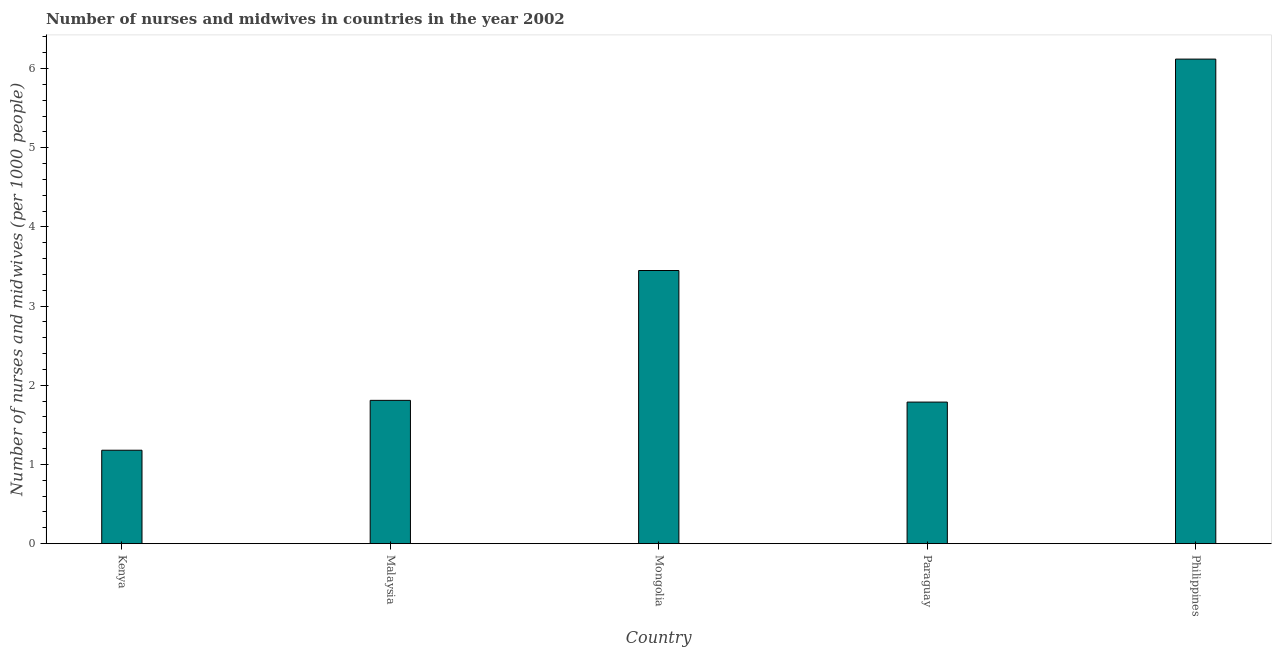Does the graph contain any zero values?
Offer a very short reply. No. What is the title of the graph?
Your answer should be compact. Number of nurses and midwives in countries in the year 2002. What is the label or title of the Y-axis?
Your answer should be very brief. Number of nurses and midwives (per 1000 people). What is the number of nurses and midwives in Mongolia?
Offer a very short reply. 3.45. Across all countries, what is the maximum number of nurses and midwives?
Offer a terse response. 6.12. Across all countries, what is the minimum number of nurses and midwives?
Provide a short and direct response. 1.18. In which country was the number of nurses and midwives minimum?
Give a very brief answer. Kenya. What is the sum of the number of nurses and midwives?
Keep it short and to the point. 14.35. What is the difference between the number of nurses and midwives in Kenya and Philippines?
Your answer should be very brief. -4.94. What is the average number of nurses and midwives per country?
Ensure brevity in your answer.  2.87. What is the median number of nurses and midwives?
Provide a succinct answer. 1.81. What is the ratio of the number of nurses and midwives in Malaysia to that in Paraguay?
Offer a terse response. 1.01. Is the number of nurses and midwives in Paraguay less than that in Philippines?
Your answer should be very brief. Yes. Is the difference between the number of nurses and midwives in Malaysia and Paraguay greater than the difference between any two countries?
Ensure brevity in your answer.  No. What is the difference between the highest and the second highest number of nurses and midwives?
Provide a short and direct response. 2.67. What is the difference between the highest and the lowest number of nurses and midwives?
Offer a very short reply. 4.94. How many bars are there?
Give a very brief answer. 5. What is the difference between two consecutive major ticks on the Y-axis?
Keep it short and to the point. 1. Are the values on the major ticks of Y-axis written in scientific E-notation?
Keep it short and to the point. No. What is the Number of nurses and midwives (per 1000 people) in Kenya?
Make the answer very short. 1.18. What is the Number of nurses and midwives (per 1000 people) of Malaysia?
Offer a terse response. 1.81. What is the Number of nurses and midwives (per 1000 people) of Mongolia?
Keep it short and to the point. 3.45. What is the Number of nurses and midwives (per 1000 people) of Paraguay?
Your response must be concise. 1.79. What is the Number of nurses and midwives (per 1000 people) in Philippines?
Keep it short and to the point. 6.12. What is the difference between the Number of nurses and midwives (per 1000 people) in Kenya and Malaysia?
Offer a terse response. -0.63. What is the difference between the Number of nurses and midwives (per 1000 people) in Kenya and Mongolia?
Offer a very short reply. -2.27. What is the difference between the Number of nurses and midwives (per 1000 people) in Kenya and Paraguay?
Give a very brief answer. -0.61. What is the difference between the Number of nurses and midwives (per 1000 people) in Kenya and Philippines?
Ensure brevity in your answer.  -4.94. What is the difference between the Number of nurses and midwives (per 1000 people) in Malaysia and Mongolia?
Your answer should be compact. -1.64. What is the difference between the Number of nurses and midwives (per 1000 people) in Malaysia and Paraguay?
Ensure brevity in your answer.  0.02. What is the difference between the Number of nurses and midwives (per 1000 people) in Malaysia and Philippines?
Offer a very short reply. -4.31. What is the difference between the Number of nurses and midwives (per 1000 people) in Mongolia and Paraguay?
Your answer should be very brief. 1.66. What is the difference between the Number of nurses and midwives (per 1000 people) in Mongolia and Philippines?
Your answer should be compact. -2.67. What is the difference between the Number of nurses and midwives (per 1000 people) in Paraguay and Philippines?
Offer a terse response. -4.33. What is the ratio of the Number of nurses and midwives (per 1000 people) in Kenya to that in Malaysia?
Ensure brevity in your answer.  0.65. What is the ratio of the Number of nurses and midwives (per 1000 people) in Kenya to that in Mongolia?
Your response must be concise. 0.34. What is the ratio of the Number of nurses and midwives (per 1000 people) in Kenya to that in Paraguay?
Give a very brief answer. 0.66. What is the ratio of the Number of nurses and midwives (per 1000 people) in Kenya to that in Philippines?
Provide a short and direct response. 0.19. What is the ratio of the Number of nurses and midwives (per 1000 people) in Malaysia to that in Mongolia?
Your answer should be very brief. 0.53. What is the ratio of the Number of nurses and midwives (per 1000 people) in Malaysia to that in Paraguay?
Offer a terse response. 1.01. What is the ratio of the Number of nurses and midwives (per 1000 people) in Malaysia to that in Philippines?
Provide a succinct answer. 0.3. What is the ratio of the Number of nurses and midwives (per 1000 people) in Mongolia to that in Paraguay?
Give a very brief answer. 1.93. What is the ratio of the Number of nurses and midwives (per 1000 people) in Mongolia to that in Philippines?
Keep it short and to the point. 0.56. What is the ratio of the Number of nurses and midwives (per 1000 people) in Paraguay to that in Philippines?
Ensure brevity in your answer.  0.29. 